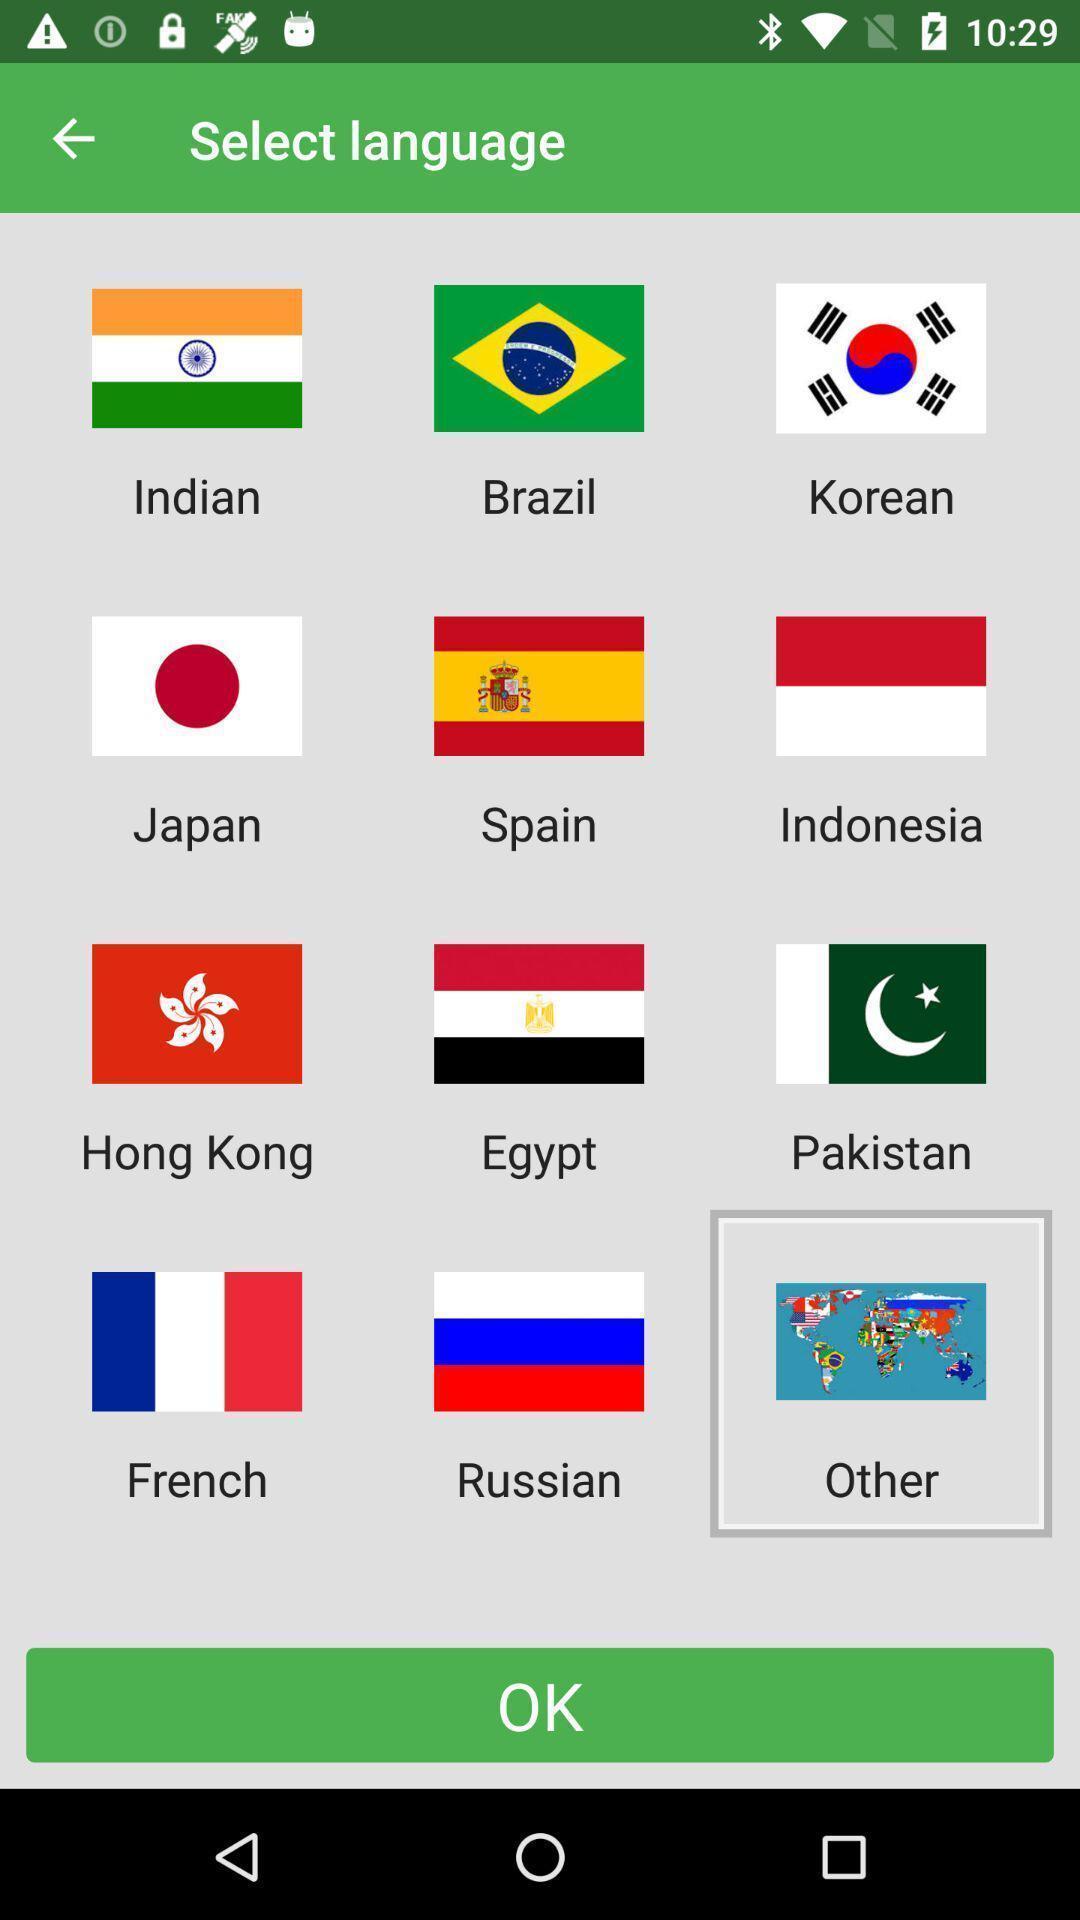Provide a textual representation of this image. Screen displaying multiple language options. 